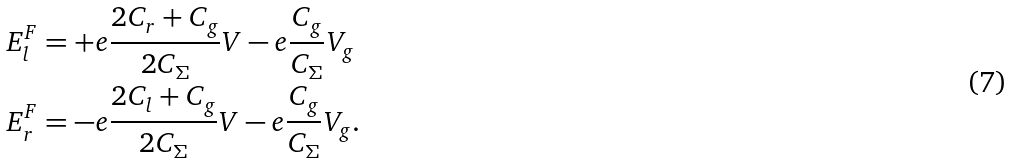Convert formula to latex. <formula><loc_0><loc_0><loc_500><loc_500>E ^ { F } _ { l } & = + e \frac { 2 C _ { r } + C _ { g } } { 2 C _ { \Sigma } } V - e \frac { C _ { g } } { C _ { \Sigma } } V _ { g } \\ E ^ { F } _ { r } & = - e \frac { 2 C _ { l } + C _ { g } } { 2 C _ { \Sigma } } V - e \frac { C _ { g } } { C _ { \Sigma } } V _ { g } .</formula> 